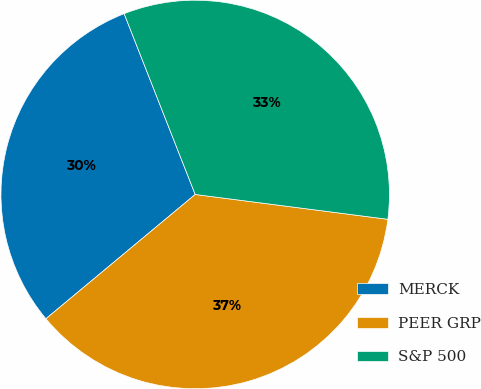Convert chart. <chart><loc_0><loc_0><loc_500><loc_500><pie_chart><fcel>MERCK<fcel>PEER GRP<fcel>S&P 500<nl><fcel>30.09%<fcel>36.91%<fcel>33.0%<nl></chart> 